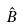Convert formula to latex. <formula><loc_0><loc_0><loc_500><loc_500>\hat { B }</formula> 